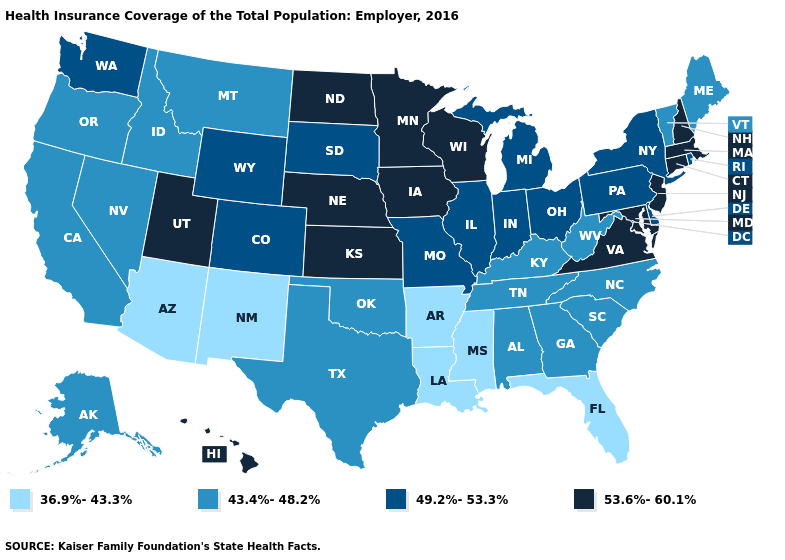What is the value of Oklahoma?
Keep it brief. 43.4%-48.2%. Name the states that have a value in the range 43.4%-48.2%?
Be succinct. Alabama, Alaska, California, Georgia, Idaho, Kentucky, Maine, Montana, Nevada, North Carolina, Oklahoma, Oregon, South Carolina, Tennessee, Texas, Vermont, West Virginia. Name the states that have a value in the range 53.6%-60.1%?
Short answer required. Connecticut, Hawaii, Iowa, Kansas, Maryland, Massachusetts, Minnesota, Nebraska, New Hampshire, New Jersey, North Dakota, Utah, Virginia, Wisconsin. What is the value of Ohio?
Concise answer only. 49.2%-53.3%. Name the states that have a value in the range 43.4%-48.2%?
Short answer required. Alabama, Alaska, California, Georgia, Idaho, Kentucky, Maine, Montana, Nevada, North Carolina, Oklahoma, Oregon, South Carolina, Tennessee, Texas, Vermont, West Virginia. What is the highest value in states that border Minnesota?
Write a very short answer. 53.6%-60.1%. Among the states that border Illinois , which have the lowest value?
Write a very short answer. Kentucky. Does the map have missing data?
Be succinct. No. What is the value of Alabama?
Answer briefly. 43.4%-48.2%. How many symbols are there in the legend?
Quick response, please. 4. Is the legend a continuous bar?
Be succinct. No. Does Florida have a lower value than Nevada?
Answer briefly. Yes. What is the value of Vermont?
Quick response, please. 43.4%-48.2%. Which states have the highest value in the USA?
Give a very brief answer. Connecticut, Hawaii, Iowa, Kansas, Maryland, Massachusetts, Minnesota, Nebraska, New Hampshire, New Jersey, North Dakota, Utah, Virginia, Wisconsin. Name the states that have a value in the range 49.2%-53.3%?
Keep it brief. Colorado, Delaware, Illinois, Indiana, Michigan, Missouri, New York, Ohio, Pennsylvania, Rhode Island, South Dakota, Washington, Wyoming. 